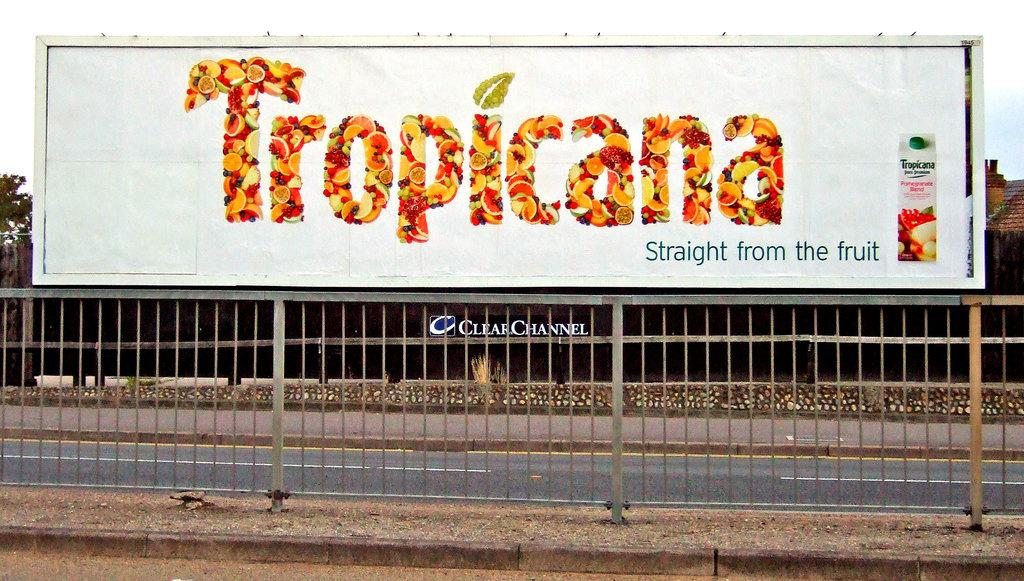<image>
Write a terse but informative summary of the picture. A billboard for Tropicana has a phrase that reads "Straight from the fruit." 